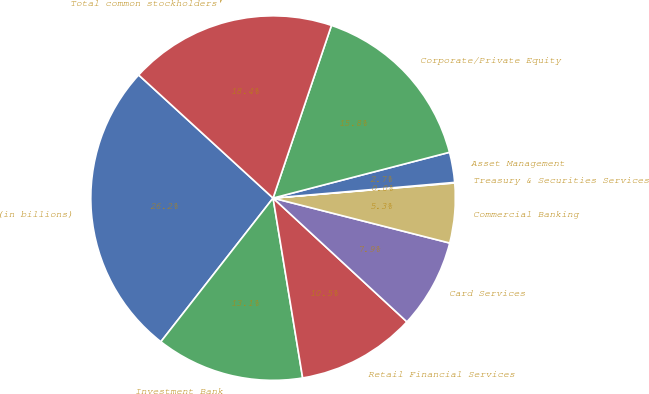Convert chart. <chart><loc_0><loc_0><loc_500><loc_500><pie_chart><fcel>(in billions)<fcel>Investment Bank<fcel>Retail Financial Services<fcel>Card Services<fcel>Commercial Banking<fcel>Treasury & Securities Services<fcel>Asset Management<fcel>Corporate/Private Equity<fcel>Total common stockholders'<nl><fcel>26.25%<fcel>13.15%<fcel>10.53%<fcel>7.91%<fcel>5.29%<fcel>0.05%<fcel>2.67%<fcel>15.77%<fcel>18.39%<nl></chart> 